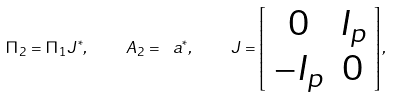Convert formula to latex. <formula><loc_0><loc_0><loc_500><loc_500>\Pi _ { 2 } = \Pi _ { 1 } J ^ { * } , \quad A _ { 2 } = \ a ^ { * } , \quad J = \left [ \begin{array} { c c } 0 & I _ { p } \\ - I _ { p } & 0 \end{array} \right ] ,</formula> 